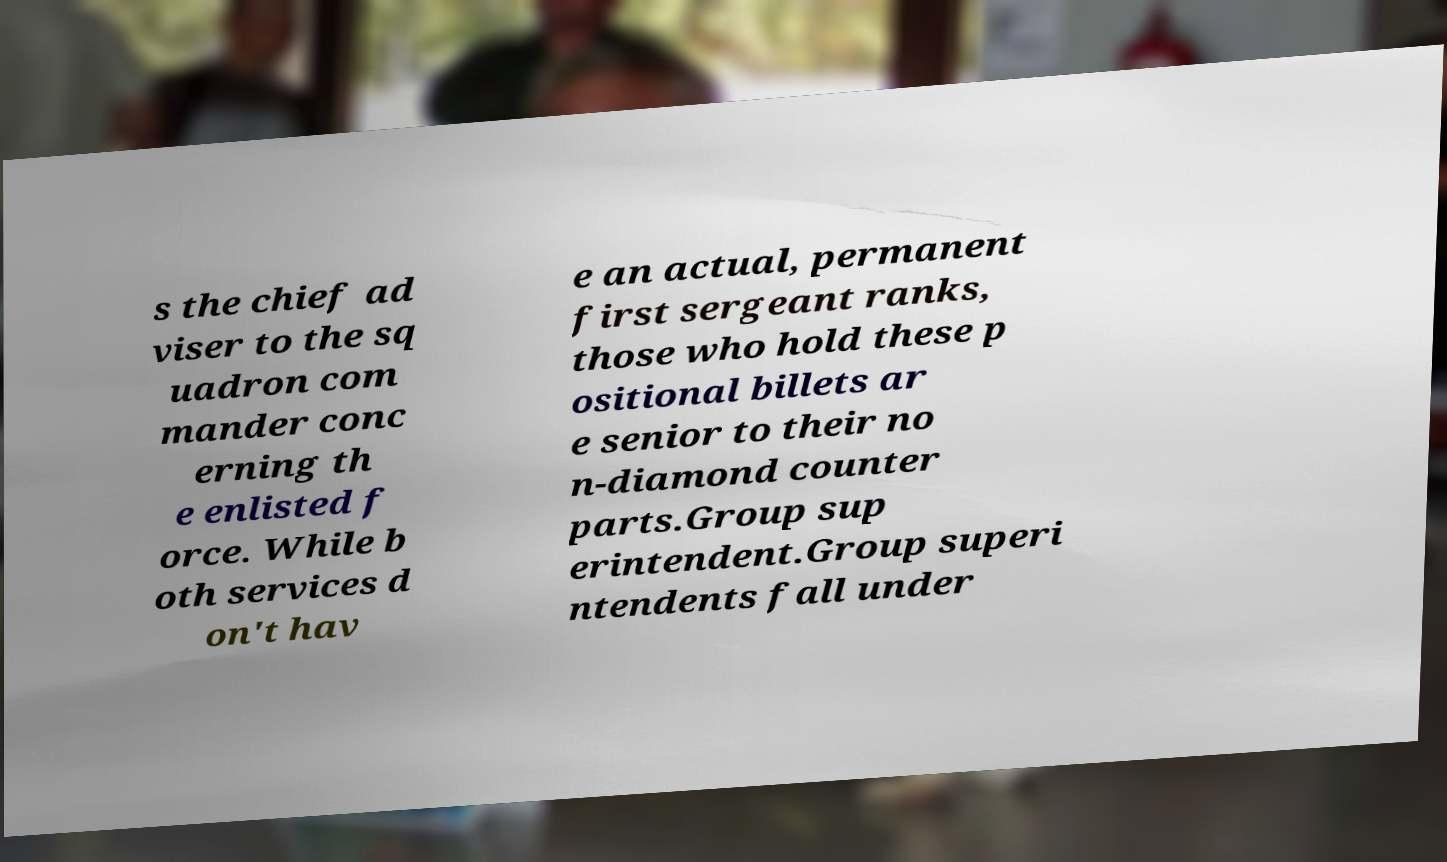Could you assist in decoding the text presented in this image and type it out clearly? s the chief ad viser to the sq uadron com mander conc erning th e enlisted f orce. While b oth services d on't hav e an actual, permanent first sergeant ranks, those who hold these p ositional billets ar e senior to their no n-diamond counter parts.Group sup erintendent.Group superi ntendents fall under 